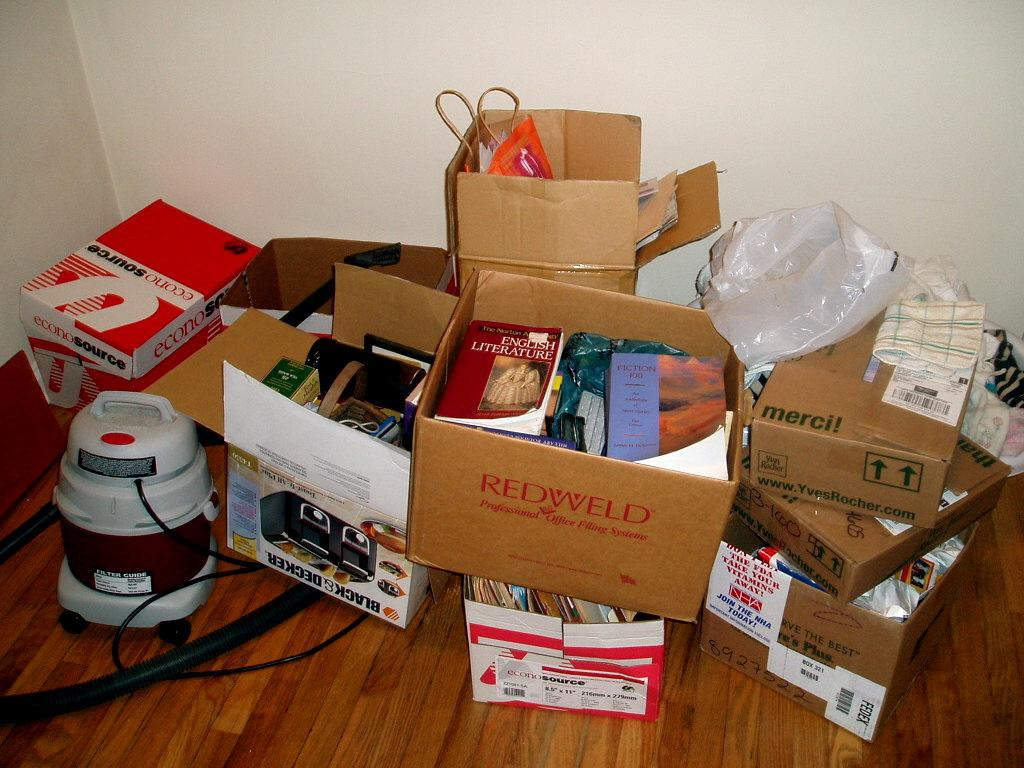Provide a one-sentence caption for the provided image. A Black and Decker toaster box is in a stack of other boxes. 